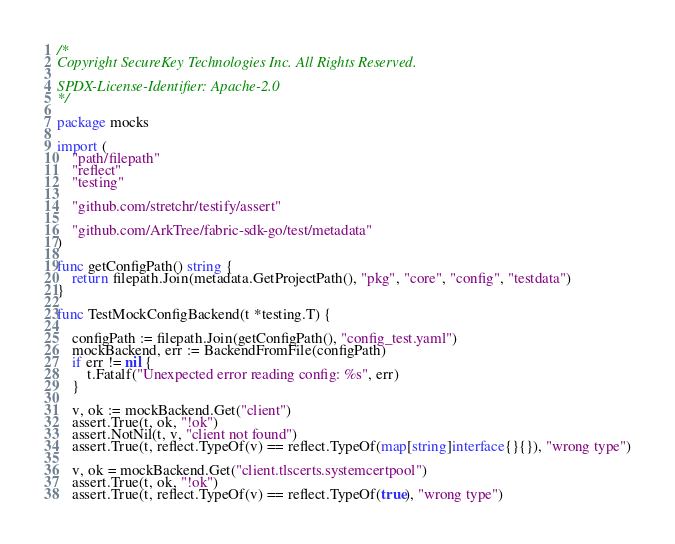<code> <loc_0><loc_0><loc_500><loc_500><_Go_>/*
Copyright SecureKey Technologies Inc. All Rights Reserved.

SPDX-License-Identifier: Apache-2.0
*/

package mocks

import (
	"path/filepath"
	"reflect"
	"testing"

	"github.com/stretchr/testify/assert"

	"github.com/ArkTree/fabric-sdk-go/test/metadata"
)

func getConfigPath() string {
	return filepath.Join(metadata.GetProjectPath(), "pkg", "core", "config", "testdata")
}

func TestMockConfigBackend(t *testing.T) {

	configPath := filepath.Join(getConfigPath(), "config_test.yaml")
	mockBackend, err := BackendFromFile(configPath)
	if err != nil {
		t.Fatalf("Unexpected error reading config: %s", err)
	}

	v, ok := mockBackend.Get("client")
	assert.True(t, ok, "!ok")
	assert.NotNil(t, v, "client not found")
	assert.True(t, reflect.TypeOf(v) == reflect.TypeOf(map[string]interface{}{}), "wrong type")

	v, ok = mockBackend.Get("client.tlscerts.systemcertpool")
	assert.True(t, ok, "!ok")
	assert.True(t, reflect.TypeOf(v) == reflect.TypeOf(true), "wrong type")</code> 